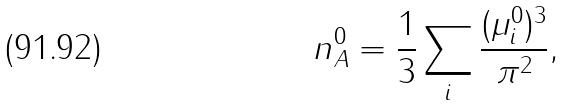Convert formula to latex. <formula><loc_0><loc_0><loc_500><loc_500>n _ { A } ^ { 0 } = { \frac { 1 } { 3 } } \sum _ { i } { \frac { ( \mu _ { i } ^ { 0 } ) ^ { 3 } } { \pi ^ { 2 } } } ,</formula> 